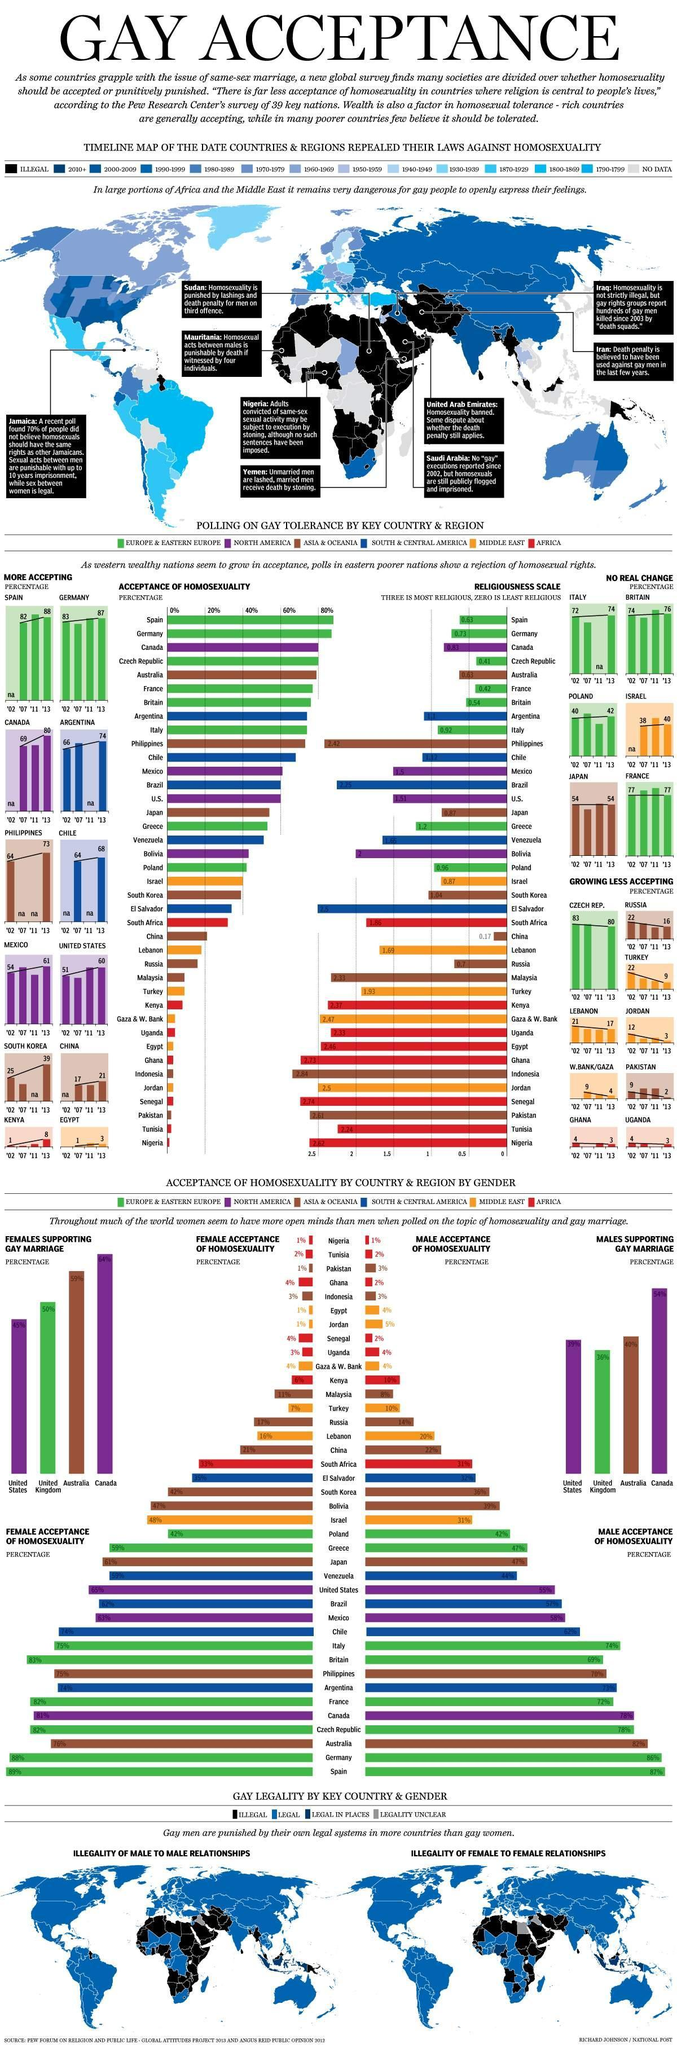Which country has the second highest percentage of females supporting gay marriage?
Answer the question with a short phrase. Australia Which country has the least percentage of females supporting gay marriage? United States Which country has the highest percentage of females supporting gay marriage? Canada What is the percentage of female acceptance of homosexuality in Ghana? 4% What is the percentage of male acceptance of homosexuality in china? 22% Which country has the highest percentage of male acceptance of homosexuality? Spain Which country has the second highest percentage of female acceptance of homosexuality? Germany What is the percentage of male acceptance of homosexuality in Malaysia? 8% 